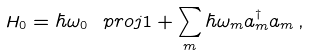Convert formula to latex. <formula><loc_0><loc_0><loc_500><loc_500>H _ { 0 } = \hbar { \omega } _ { 0 } \ p r o j { 1 } + \sum _ { m } \hbar { \omega } _ { m } a ^ { \dagger } _ { m } a _ { m } \, ,</formula> 